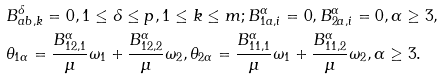<formula> <loc_0><loc_0><loc_500><loc_500>& B ^ { \delta } _ { a b , k } = 0 , 1 \leq \delta \leq p , 1 \leq k \leq m ; B ^ { \alpha } _ { 1 a , i } = 0 , B ^ { \alpha } _ { 2 a , i } = 0 , \alpha \geq 3 , \\ & \theta _ { 1 \alpha } = \frac { B ^ { \alpha } _ { 1 2 , 1 } } { \mu } \omega _ { 1 } + \frac { B ^ { \alpha } _ { 1 2 , 2 } } { \mu } \omega _ { 2 } , \theta _ { 2 \alpha } = \frac { B ^ { \alpha } _ { 1 1 , 1 } } { \mu } \omega _ { 1 } + \frac { B ^ { \alpha } _ { 1 1 , 2 } } { \mu } \omega _ { 2 } , \alpha \geq 3 .</formula> 